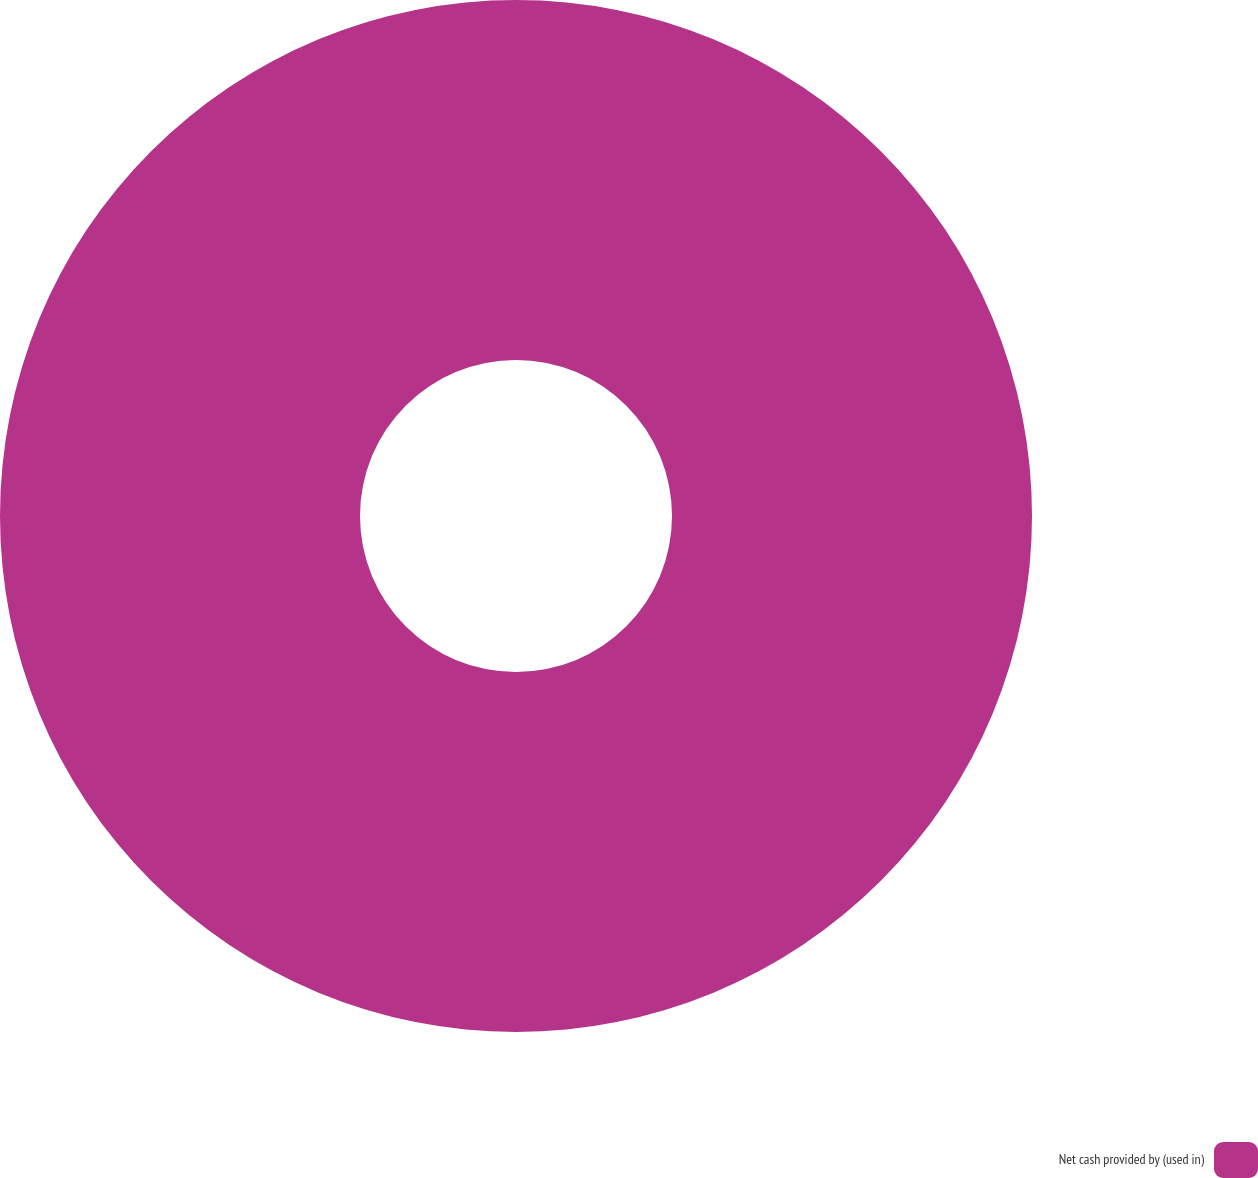<chart> <loc_0><loc_0><loc_500><loc_500><pie_chart><fcel>Net cash provided by (used in)<nl><fcel>100.0%<nl></chart> 